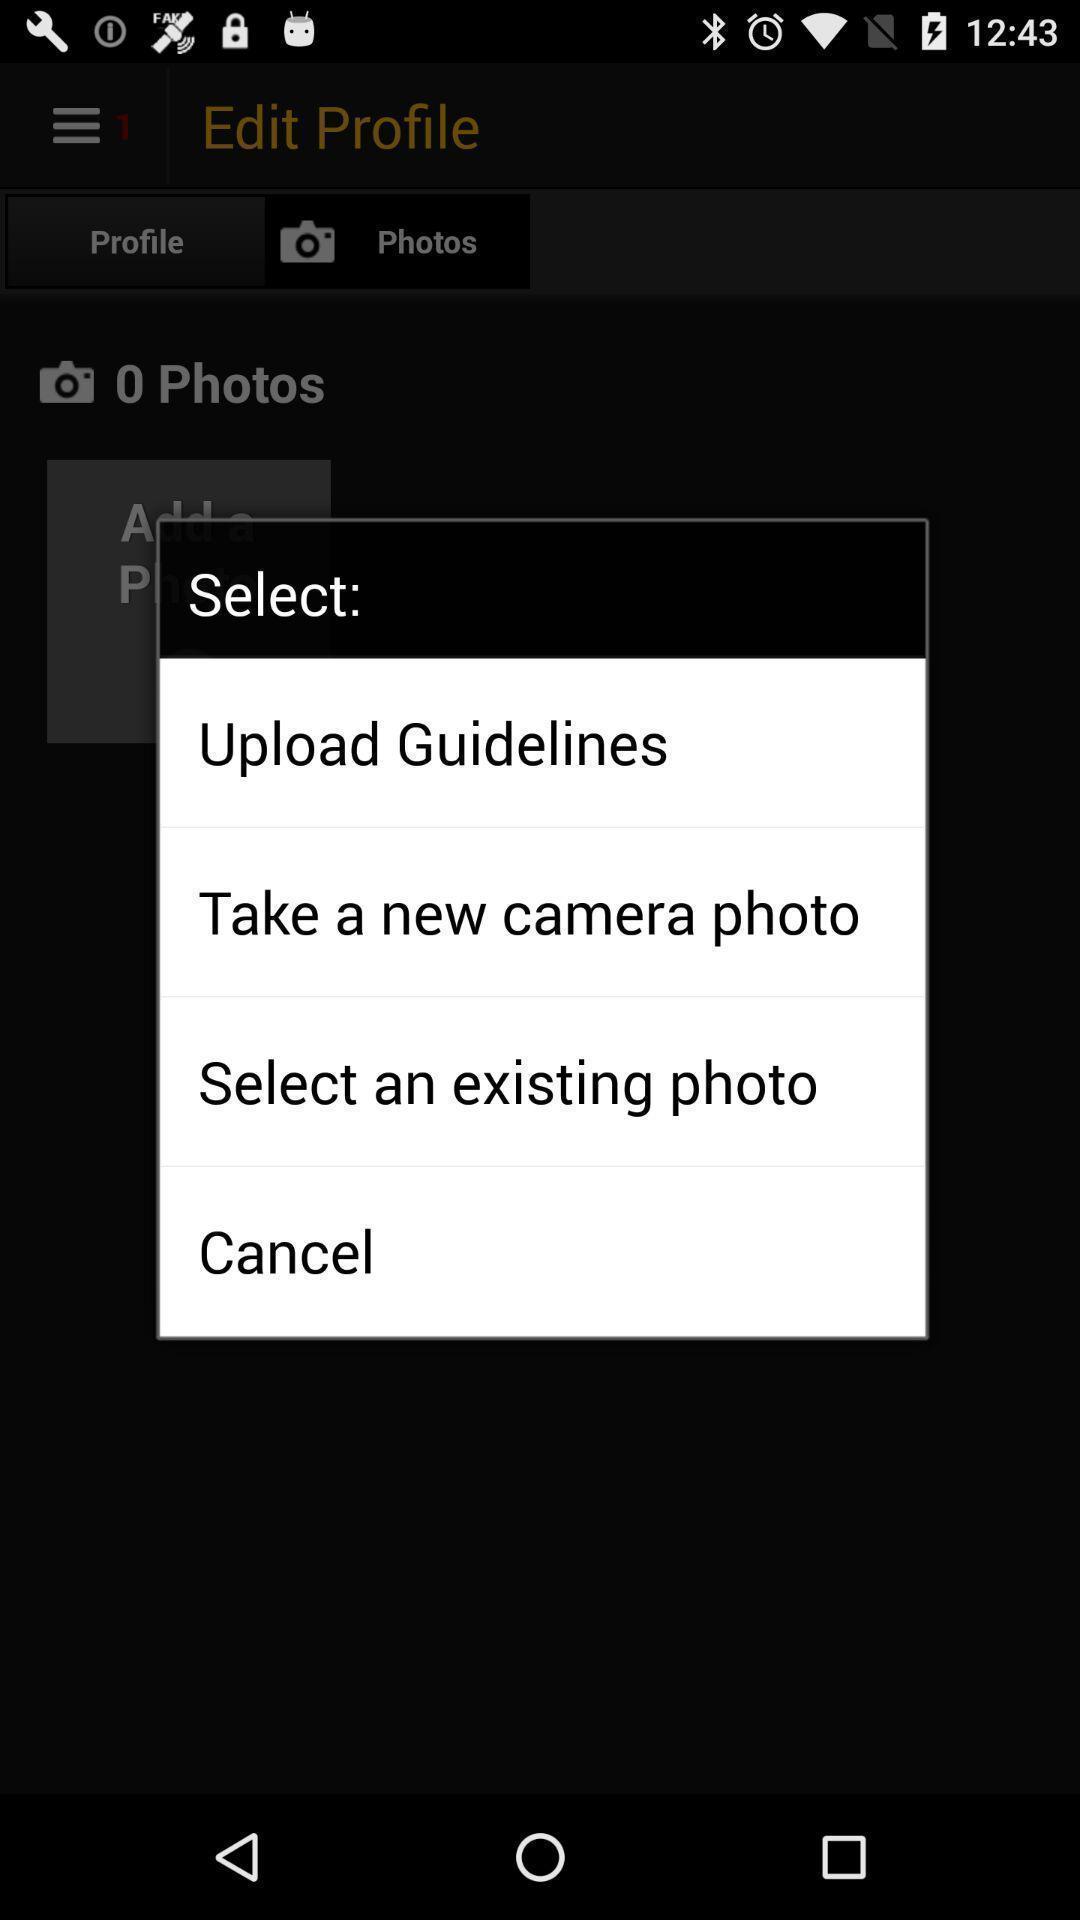Tell me about the visual elements in this screen capture. Pop-up window showing different options for uploading photo. 